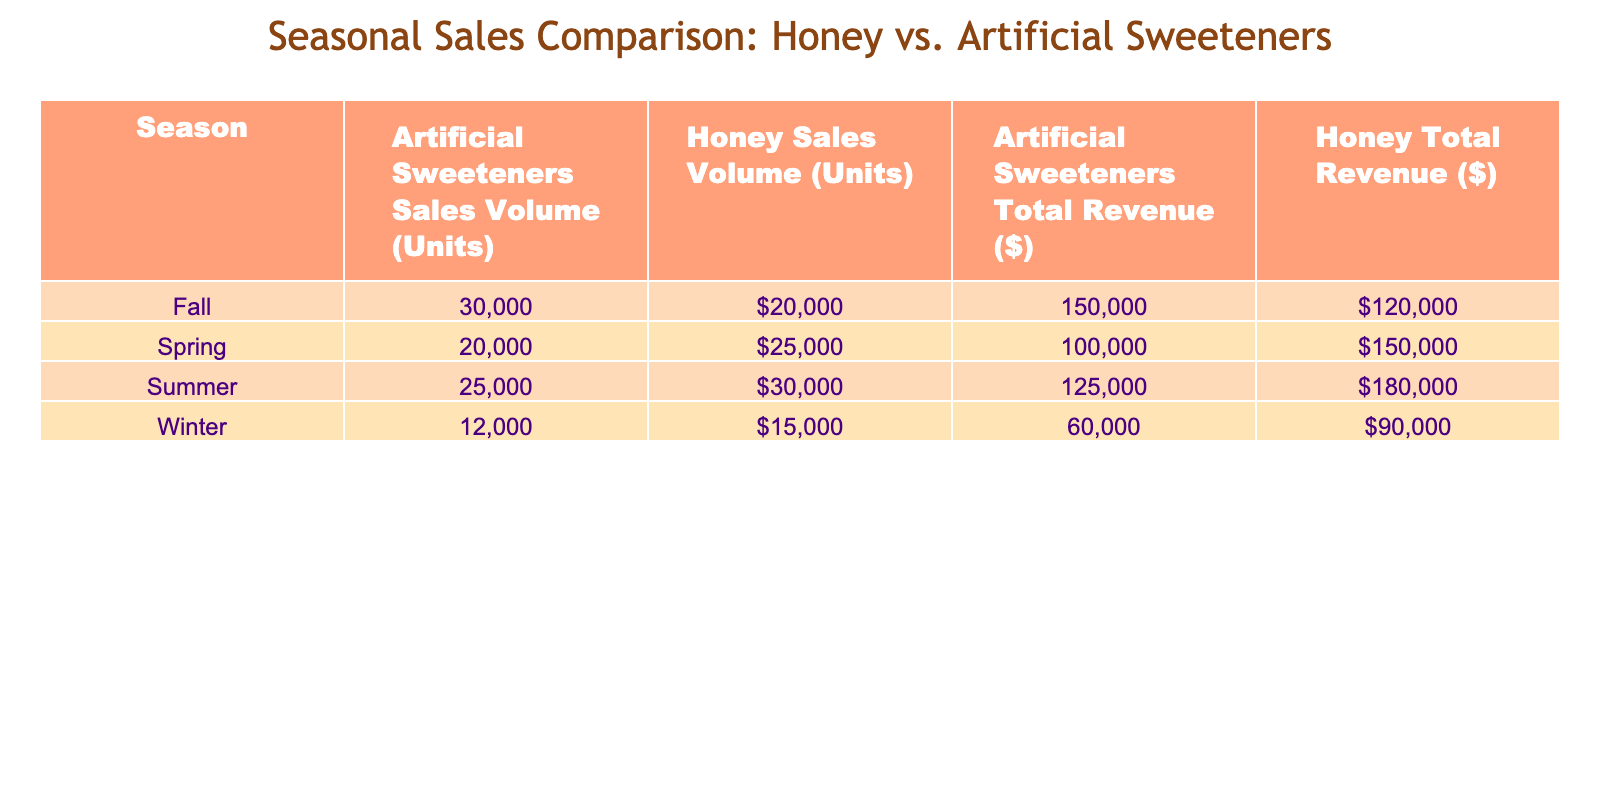What was the total sales volume of Honey during the Spring season? The table states that in Spring, the sales volume for Honey is 25000 units. Therefore, the total sales volume for Honey during the Spring season is directly stated in the table.
Answer: 25000 units Which product had the highest total revenue in the Fall? The table indicates that in Fall, Honey has a total revenue of $120000 while Artificial Sweeteners have $150000. Thus, Artificial Sweeteners had the highest total revenue in the Fall season.
Answer: Artificial Sweeteners What is the difference in sales volume between Summer Honey and Summer Artificial Sweeteners? In the Summer, the sales volume for Honey is 30000 units, and for Artificial Sweeteners, it is 25000 units. The difference can be calculated as 30000 - 25000 = 5000 units. Therefore, the difference in sales volume is 5000 units.
Answer: 5000 units Did Honey generate more revenue than Artificial Sweeteners in Winter? In Winter, Honey had a total revenue of $90000 and Artificial Sweeteners had $60000. Since $90000 is greater than $60000, Honey did generate more revenue than Artificial Sweeteners in Winter.
Answer: Yes What was the overall total revenue from all products in the Spring season? For the Spring season, Honey's revenue is $150000 and Artificial Sweeteners' revenue is $100000. The overall total revenue is calculated as $150000 + $100000 = $250000.
Answer: $250000 Which product had greater sales volume throughout all seasons combined? To assess this, we sum the sales volume for each product across all seasons. For Honey: 15000 + 25000 + 30000 + 20000 = 90000 units; for Artificial Sweeteners: 12000 + 20000 + 25000 + 30000 = 87000 units. Honey has the greater total sales volume.
Answer: Honey Was there a season where sales of both Honey and Artificial Sweeteners were equal? Looking through the table, checking each season: Winter (Honey 15000, Sweeteners 12000), Spring (Honey 25000, Sweeteners 20000), Summer (Honey 30000, Sweeteners 25000), Fall (Honey 20000, Sweeteners 30000). There were no seasons where the sales volumes were equal for both products.
Answer: No What is the average sales volume of Honey across the four seasons? The sales volumes for Honey across the seasons are 15000 (Winter), 25000 (Spring), 30000 (Summer), and 20000 (Fall). Adding these gives a total of 90000 units. To find the average, we divide by the number of seasons (4), thus 90000 / 4 = 22500 units.
Answer: 22500 units In which season did Artificial Sweeteners see the highest sales volume? From the table, checking the sales volumes for Artificial Sweeteners: 12000 (Winter), 20000 (Spring), 25000 (Summer), and 30000 (Fall). The highest sales volume occurred in Fall, which had a sales volume of 30000 units.
Answer: Fall 